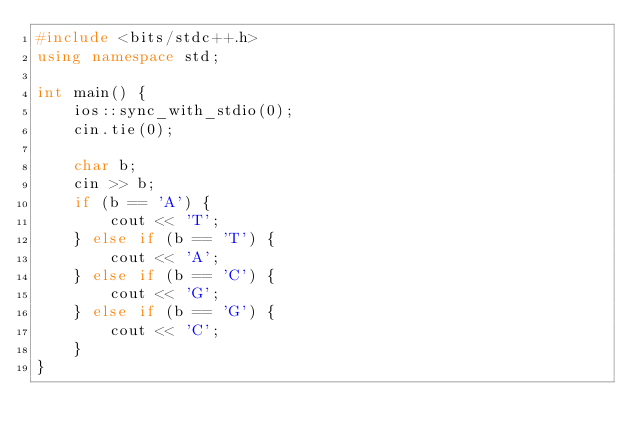Convert code to text. <code><loc_0><loc_0><loc_500><loc_500><_C++_>#include <bits/stdc++.h>
using namespace std;

int main() {
    ios::sync_with_stdio(0);
    cin.tie(0);

    char b;
    cin >> b;
    if (b == 'A') {
        cout << 'T';
    } else if (b == 'T') {
        cout << 'A';
    } else if (b == 'C') {
        cout << 'G';
    } else if (b == 'G') {
        cout << 'C';
    }
}</code> 